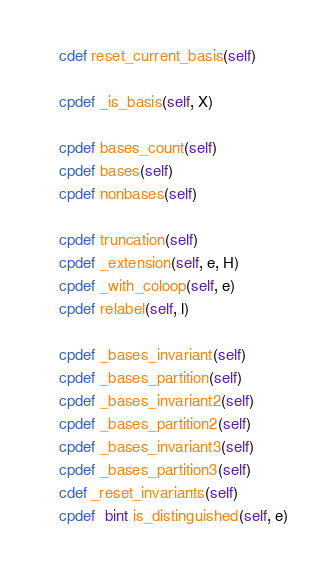Convert code to text. <code><loc_0><loc_0><loc_500><loc_500><_Cython_>
    cdef reset_current_basis(self)

    cpdef _is_basis(self, X)

    cpdef bases_count(self)
    cpdef bases(self)
    cpdef nonbases(self)

    cpdef truncation(self)
    cpdef _extension(self, e, H)
    cpdef _with_coloop(self, e)
    cpdef relabel(self, l)

    cpdef _bases_invariant(self)
    cpdef _bases_partition(self)
    cpdef _bases_invariant2(self)
    cpdef _bases_partition2(self)
    cpdef _bases_invariant3(self)
    cpdef _bases_partition3(self)
    cdef _reset_invariants(self)
    cpdef  bint is_distinguished(self, e)</code> 